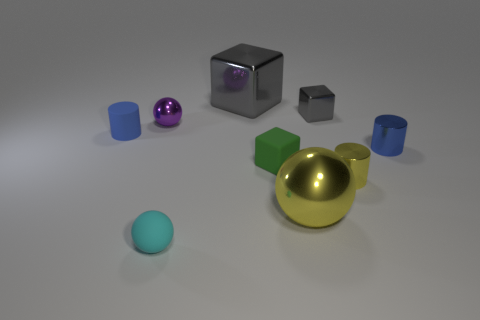What is the size of the metal thing that is the same color as the tiny metal cube?
Your answer should be compact. Large. There is another cylinder that is the same color as the rubber cylinder; what material is it?
Offer a terse response. Metal. How many blocks are big things or rubber things?
Your response must be concise. 2. Are the small gray object and the green object made of the same material?
Give a very brief answer. No. How many other things are the same color as the rubber sphere?
Ensure brevity in your answer.  0. There is a small metallic thing to the right of the small yellow cylinder; what is its shape?
Provide a succinct answer. Cylinder. How many things are big gray shiny things or gray metal things?
Keep it short and to the point. 2. Does the yellow cylinder have the same size as the gray block that is to the right of the big gray metallic thing?
Your answer should be very brief. Yes. How many other things are there of the same material as the purple sphere?
Offer a very short reply. 5. What number of things are either tiny blocks behind the tiny purple metallic ball or blue cylinders on the right side of the blue matte cylinder?
Provide a short and direct response. 2. 